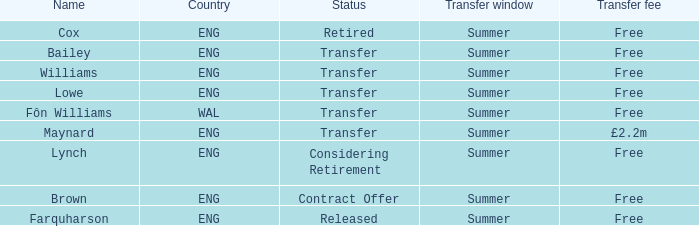What is Brown's transfer window? Summer. 